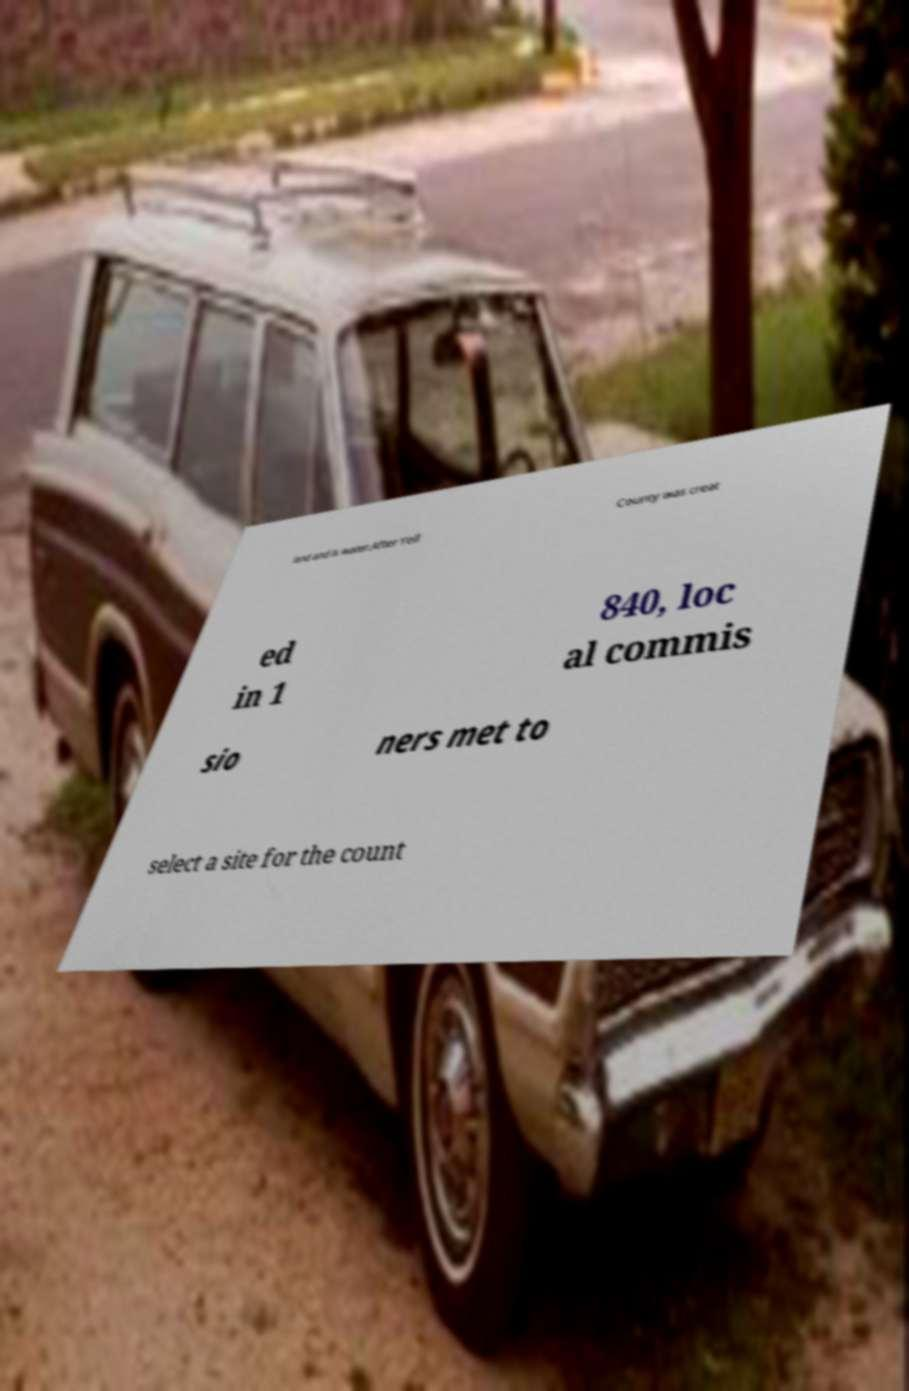What messages or text are displayed in this image? I need them in a readable, typed format. land and is water.After Yell County was creat ed in 1 840, loc al commis sio ners met to select a site for the count 